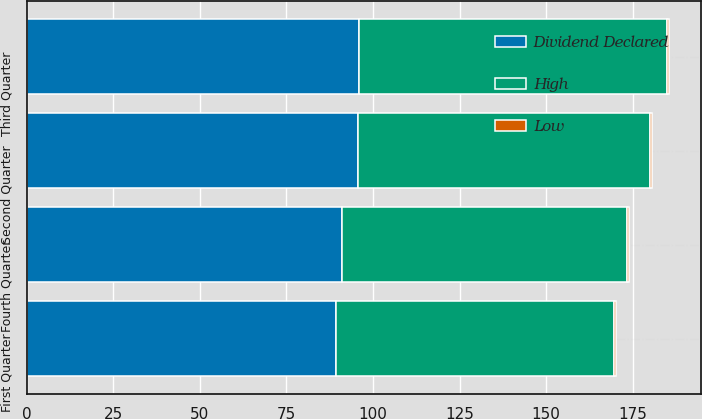<chart> <loc_0><loc_0><loc_500><loc_500><stacked_bar_chart><ecel><fcel>First Quarter<fcel>Second Quarter<fcel>Third Quarter<fcel>Fourth Quarter<nl><fcel>Dividend Declared<fcel>89.33<fcel>95.6<fcel>95.95<fcel>90.99<nl><fcel>High<fcel>80.26<fcel>84.39<fcel>89.12<fcel>82.35<nl><fcel>Low<fcel>0.5<fcel>0.55<fcel>0.55<fcel>0.5<nl></chart> 